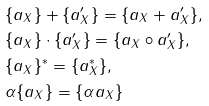<formula> <loc_0><loc_0><loc_500><loc_500>& \{ a _ { X } \} + \{ a ^ { \prime } _ { X } \} = \{ a _ { X } + a ^ { \prime } _ { X } \} , \\ & \{ a _ { X } \} \cdot \{ a ^ { \prime } _ { X } \} = \{ a _ { X } \circ a ^ { \prime } _ { X } \} , \\ & \{ a _ { X } \} ^ { * } = \{ a _ { X } ^ { * } \} , \\ & \alpha \{ a _ { X } \} = \{ \alpha a _ { X } \}</formula> 